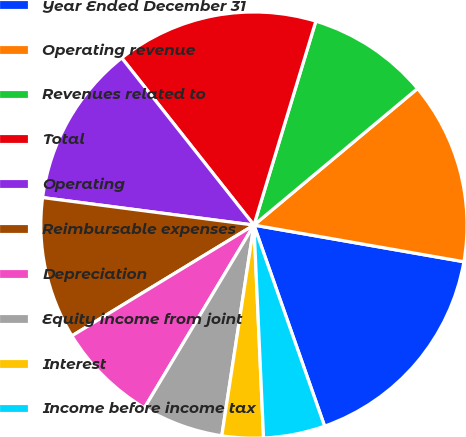Convert chart to OTSL. <chart><loc_0><loc_0><loc_500><loc_500><pie_chart><fcel>Year Ended December 31<fcel>Operating revenue<fcel>Revenues related to<fcel>Total<fcel>Operating<fcel>Reimbursable expenses<fcel>Depreciation<fcel>Equity income from joint<fcel>Interest<fcel>Income before income tax<nl><fcel>16.87%<fcel>13.82%<fcel>9.24%<fcel>15.34%<fcel>12.29%<fcel>10.76%<fcel>7.71%<fcel>6.18%<fcel>3.13%<fcel>4.66%<nl></chart> 